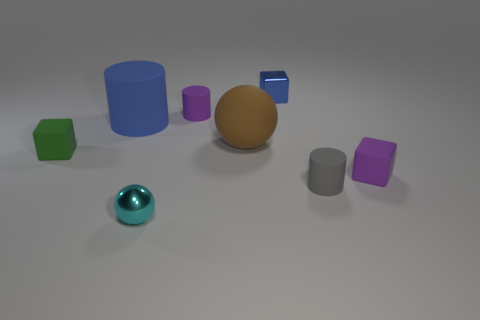There is a small rubber object that is both to the left of the tiny gray object and right of the small cyan ball; what is its shape?
Your answer should be compact. Cylinder. What is the size of the thing that is the same color as the large rubber cylinder?
Keep it short and to the point. Small. Do the small cyan metallic thing and the large matte thing that is to the right of the blue cylinder have the same shape?
Your answer should be compact. Yes. Is there a metallic cube that has the same color as the big cylinder?
Offer a terse response. Yes. There is a blue thing that is the same material as the tiny purple cylinder; what size is it?
Offer a very short reply. Large. Does the tiny metallic block have the same color as the large rubber cylinder?
Give a very brief answer. Yes. There is a small purple matte thing that is left of the blue metal object; is its shape the same as the gray object?
Give a very brief answer. Yes. What number of blue metal objects have the same size as the green object?
Offer a very short reply. 1. What is the shape of the thing that is the same color as the metal block?
Give a very brief answer. Cylinder. There is a ball that is in front of the purple rubber cube; is there a tiny object that is to the left of it?
Your answer should be very brief. Yes. 